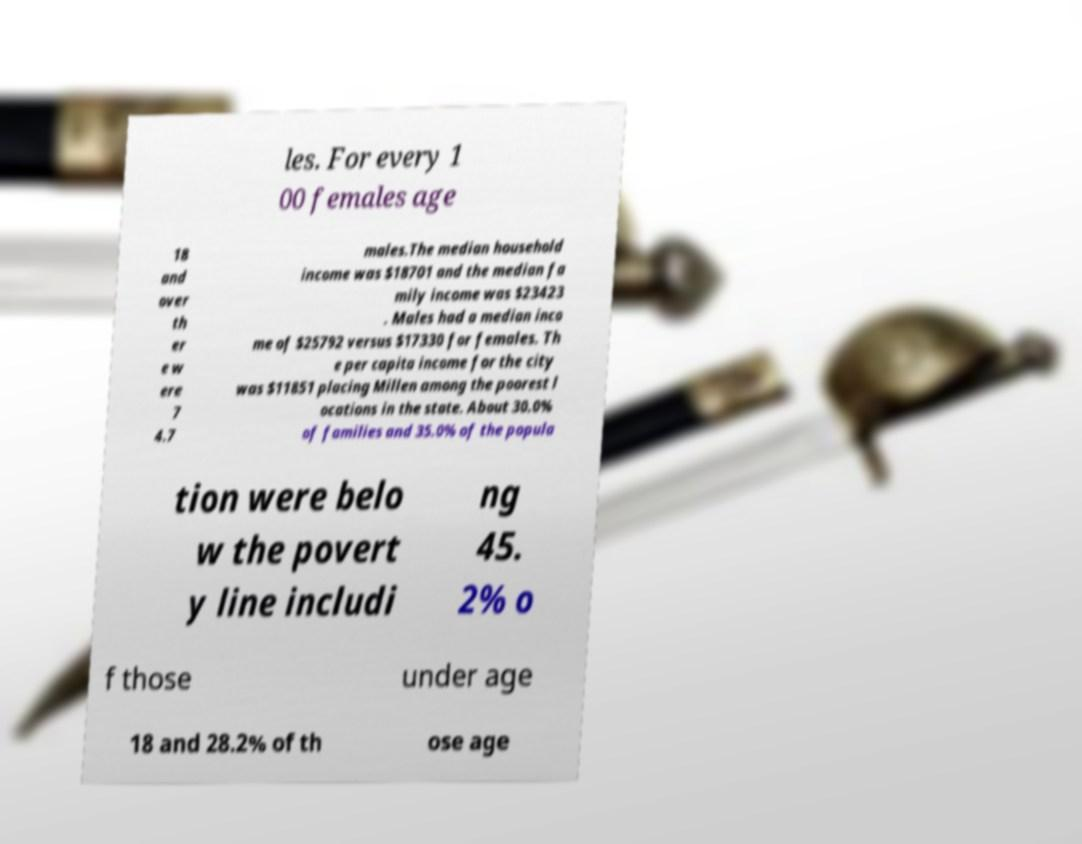What messages or text are displayed in this image? I need them in a readable, typed format. les. For every 1 00 females age 18 and over th er e w ere 7 4.7 males.The median household income was $18701 and the median fa mily income was $23423 . Males had a median inco me of $25792 versus $17330 for females. Th e per capita income for the city was $11851 placing Millen among the poorest l ocations in the state. About 30.0% of families and 35.0% of the popula tion were belo w the povert y line includi ng 45. 2% o f those under age 18 and 28.2% of th ose age 